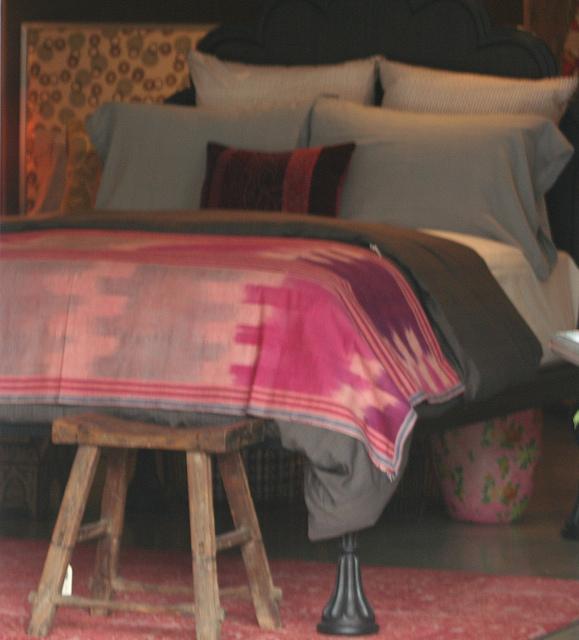Are there at least 4 tones in the red family of colors, here?
Keep it brief. Yes. How many pillows are on the bed?
Quick response, please. 5. What is holding up the bed?
Be succinct. Stool. 